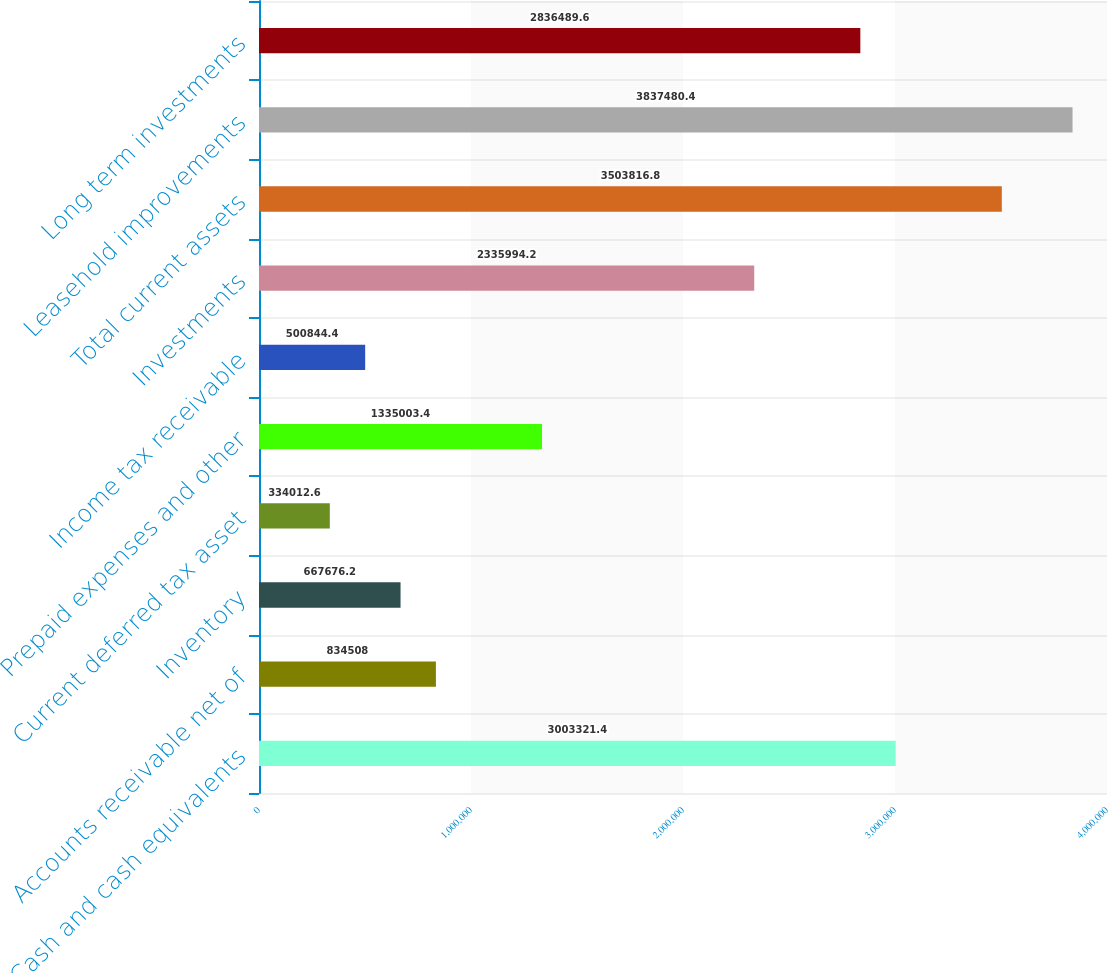<chart> <loc_0><loc_0><loc_500><loc_500><bar_chart><fcel>Cash and cash equivalents<fcel>Accounts receivable net of<fcel>Inventory<fcel>Current deferred tax asset<fcel>Prepaid expenses and other<fcel>Income tax receivable<fcel>Investments<fcel>Total current assets<fcel>Leasehold improvements<fcel>Long term investments<nl><fcel>3.00332e+06<fcel>834508<fcel>667676<fcel>334013<fcel>1.335e+06<fcel>500844<fcel>2.33599e+06<fcel>3.50382e+06<fcel>3.83748e+06<fcel>2.83649e+06<nl></chart> 